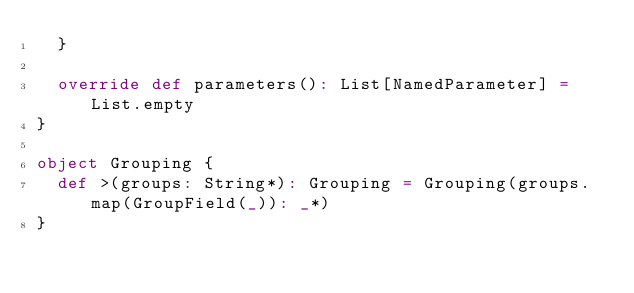<code> <loc_0><loc_0><loc_500><loc_500><_Scala_>  }

  override def parameters(): List[NamedParameter] = List.empty
}

object Grouping {
  def >(groups: String*): Grouping = Grouping(groups.map(GroupField(_)): _*)
}
</code> 